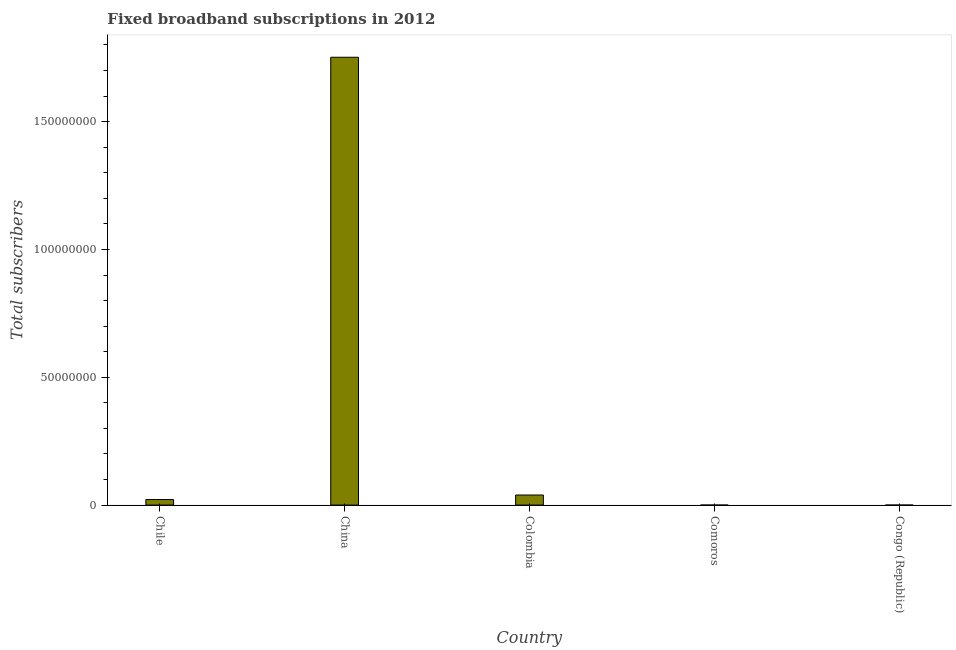Does the graph contain grids?
Make the answer very short. No. What is the title of the graph?
Give a very brief answer. Fixed broadband subscriptions in 2012. What is the label or title of the Y-axis?
Keep it short and to the point. Total subscribers. What is the total number of fixed broadband subscriptions in Comoros?
Your answer should be compact. 1233. Across all countries, what is the maximum total number of fixed broadband subscriptions?
Provide a succinct answer. 1.75e+08. Across all countries, what is the minimum total number of fixed broadband subscriptions?
Give a very brief answer. 1233. In which country was the total number of fixed broadband subscriptions maximum?
Your response must be concise. China. In which country was the total number of fixed broadband subscriptions minimum?
Your response must be concise. Comoros. What is the sum of the total number of fixed broadband subscriptions?
Offer a terse response. 1.81e+08. What is the difference between the total number of fixed broadband subscriptions in China and Colombia?
Provide a succinct answer. 1.71e+08. What is the average total number of fixed broadband subscriptions per country?
Keep it short and to the point. 3.63e+07. What is the median total number of fixed broadband subscriptions?
Provide a succinct answer. 2.17e+06. In how many countries, is the total number of fixed broadband subscriptions greater than 90000000 ?
Make the answer very short. 1. What is the ratio of the total number of fixed broadband subscriptions in China to that in Comoros?
Your response must be concise. 1.42e+05. Is the total number of fixed broadband subscriptions in Colombia less than that in Congo (Republic)?
Your response must be concise. No. Is the difference between the total number of fixed broadband subscriptions in Chile and Comoros greater than the difference between any two countries?
Ensure brevity in your answer.  No. What is the difference between the highest and the second highest total number of fixed broadband subscriptions?
Offer a terse response. 1.71e+08. What is the difference between the highest and the lowest total number of fixed broadband subscriptions?
Give a very brief answer. 1.75e+08. In how many countries, is the total number of fixed broadband subscriptions greater than the average total number of fixed broadband subscriptions taken over all countries?
Provide a succinct answer. 1. Are the values on the major ticks of Y-axis written in scientific E-notation?
Your answer should be compact. No. What is the Total subscribers of Chile?
Offer a very short reply. 2.17e+06. What is the Total subscribers in China?
Give a very brief answer. 1.75e+08. What is the Total subscribers of Colombia?
Your answer should be very brief. 3.94e+06. What is the Total subscribers of Comoros?
Your answer should be compact. 1233. What is the Total subscribers of Congo (Republic)?
Your answer should be very brief. 1392. What is the difference between the Total subscribers in Chile and China?
Provide a short and direct response. -1.73e+08. What is the difference between the Total subscribers in Chile and Colombia?
Your answer should be compact. -1.77e+06. What is the difference between the Total subscribers in Chile and Comoros?
Keep it short and to the point. 2.17e+06. What is the difference between the Total subscribers in Chile and Congo (Republic)?
Give a very brief answer. 2.16e+06. What is the difference between the Total subscribers in China and Colombia?
Your answer should be very brief. 1.71e+08. What is the difference between the Total subscribers in China and Comoros?
Provide a succinct answer. 1.75e+08. What is the difference between the Total subscribers in China and Congo (Republic)?
Your answer should be compact. 1.75e+08. What is the difference between the Total subscribers in Colombia and Comoros?
Your answer should be compact. 3.94e+06. What is the difference between the Total subscribers in Colombia and Congo (Republic)?
Provide a short and direct response. 3.94e+06. What is the difference between the Total subscribers in Comoros and Congo (Republic)?
Keep it short and to the point. -159. What is the ratio of the Total subscribers in Chile to that in China?
Ensure brevity in your answer.  0.01. What is the ratio of the Total subscribers in Chile to that in Colombia?
Offer a very short reply. 0.55. What is the ratio of the Total subscribers in Chile to that in Comoros?
Your answer should be very brief. 1756.96. What is the ratio of the Total subscribers in Chile to that in Congo (Republic)?
Offer a very short reply. 1556.27. What is the ratio of the Total subscribers in China to that in Colombia?
Ensure brevity in your answer.  44.48. What is the ratio of the Total subscribers in China to that in Comoros?
Offer a very short reply. 1.42e+05. What is the ratio of the Total subscribers in China to that in Congo (Republic)?
Give a very brief answer. 1.26e+05. What is the ratio of the Total subscribers in Colombia to that in Comoros?
Offer a very short reply. 3194.37. What is the ratio of the Total subscribers in Colombia to that in Congo (Republic)?
Your response must be concise. 2829.49. What is the ratio of the Total subscribers in Comoros to that in Congo (Republic)?
Provide a succinct answer. 0.89. 